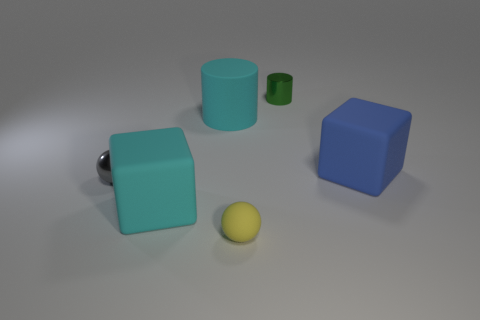Add 2 rubber cylinders. How many objects exist? 8 Subtract all blocks. How many objects are left? 4 Subtract all cyan things. Subtract all cyan rubber cubes. How many objects are left? 3 Add 1 large matte cylinders. How many large matte cylinders are left? 2 Add 2 tiny metal balls. How many tiny metal balls exist? 3 Subtract 1 cyan cubes. How many objects are left? 5 